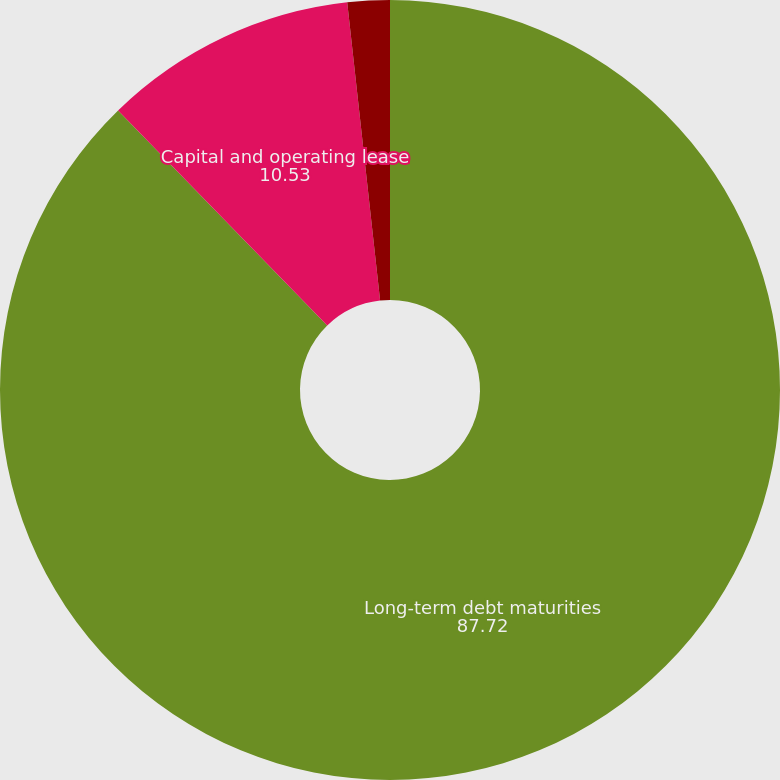Convert chart. <chart><loc_0><loc_0><loc_500><loc_500><pie_chart><fcel>Long-term debt maturities<fcel>Capital and operating lease<fcel>Unconditional fuel and<nl><fcel>87.72%<fcel>10.53%<fcel>1.75%<nl></chart> 